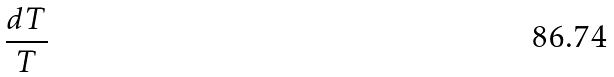Convert formula to latex. <formula><loc_0><loc_0><loc_500><loc_500>\frac { d T } { T }</formula> 